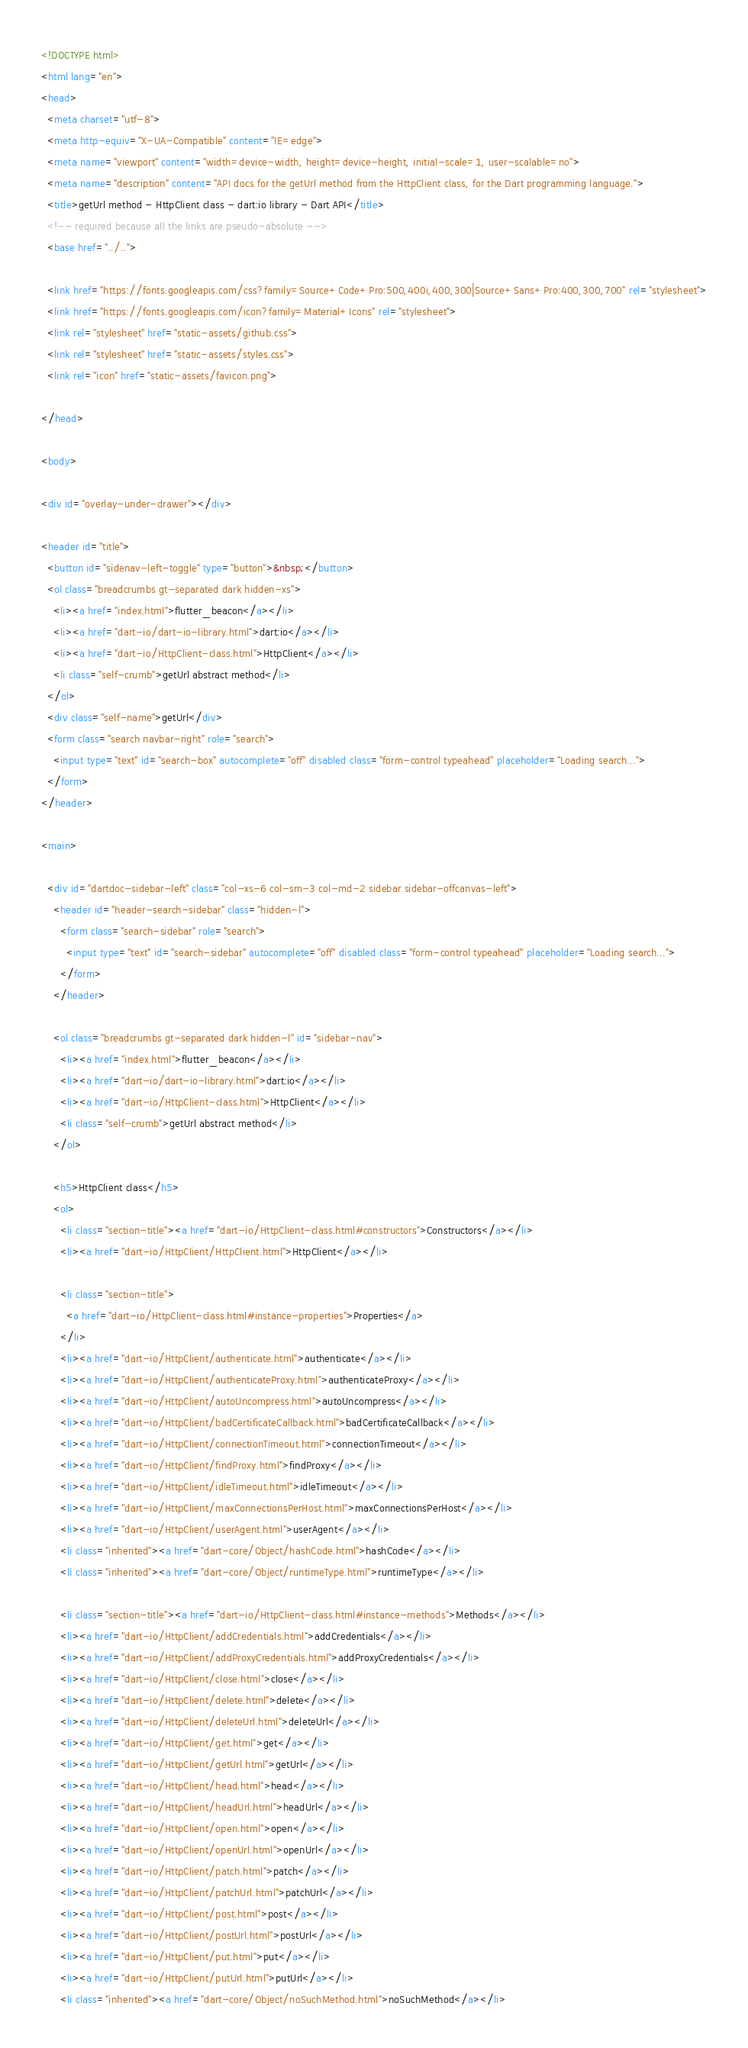<code> <loc_0><loc_0><loc_500><loc_500><_HTML_><!DOCTYPE html>
<html lang="en">
<head>
  <meta charset="utf-8">
  <meta http-equiv="X-UA-Compatible" content="IE=edge">
  <meta name="viewport" content="width=device-width, height=device-height, initial-scale=1, user-scalable=no">
  <meta name="description" content="API docs for the getUrl method from the HttpClient class, for the Dart programming language.">
  <title>getUrl method - HttpClient class - dart:io library - Dart API</title>
  <!-- required because all the links are pseudo-absolute -->
  <base href="../..">

  <link href="https://fonts.googleapis.com/css?family=Source+Code+Pro:500,400i,400,300|Source+Sans+Pro:400,300,700" rel="stylesheet">
  <link href="https://fonts.googleapis.com/icon?family=Material+Icons" rel="stylesheet">
  <link rel="stylesheet" href="static-assets/github.css">
  <link rel="stylesheet" href="static-assets/styles.css">
  <link rel="icon" href="static-assets/favicon.png">
  
</head>

<body>

<div id="overlay-under-drawer"></div>

<header id="title">
  <button id="sidenav-left-toggle" type="button">&nbsp;</button>
  <ol class="breadcrumbs gt-separated dark hidden-xs">
    <li><a href="index.html">flutter_beacon</a></li>
    <li><a href="dart-io/dart-io-library.html">dart:io</a></li>
    <li><a href="dart-io/HttpClient-class.html">HttpClient</a></li>
    <li class="self-crumb">getUrl abstract method</li>
  </ol>
  <div class="self-name">getUrl</div>
  <form class="search navbar-right" role="search">
    <input type="text" id="search-box" autocomplete="off" disabled class="form-control typeahead" placeholder="Loading search...">
  </form>
</header>

<main>

  <div id="dartdoc-sidebar-left" class="col-xs-6 col-sm-3 col-md-2 sidebar sidebar-offcanvas-left">
    <header id="header-search-sidebar" class="hidden-l">
      <form class="search-sidebar" role="search">
        <input type="text" id="search-sidebar" autocomplete="off" disabled class="form-control typeahead" placeholder="Loading search...">
      </form>
    </header>
    
    <ol class="breadcrumbs gt-separated dark hidden-l" id="sidebar-nav">
      <li><a href="index.html">flutter_beacon</a></li>
      <li><a href="dart-io/dart-io-library.html">dart:io</a></li>
      <li><a href="dart-io/HttpClient-class.html">HttpClient</a></li>
      <li class="self-crumb">getUrl abstract method</li>
    </ol>
    
    <h5>HttpClient class</h5>
    <ol>
      <li class="section-title"><a href="dart-io/HttpClient-class.html#constructors">Constructors</a></li>
      <li><a href="dart-io/HttpClient/HttpClient.html">HttpClient</a></li>
    
      <li class="section-title">
        <a href="dart-io/HttpClient-class.html#instance-properties">Properties</a>
      </li>
      <li><a href="dart-io/HttpClient/authenticate.html">authenticate</a></li>
      <li><a href="dart-io/HttpClient/authenticateProxy.html">authenticateProxy</a></li>
      <li><a href="dart-io/HttpClient/autoUncompress.html">autoUncompress</a></li>
      <li><a href="dart-io/HttpClient/badCertificateCallback.html">badCertificateCallback</a></li>
      <li><a href="dart-io/HttpClient/connectionTimeout.html">connectionTimeout</a></li>
      <li><a href="dart-io/HttpClient/findProxy.html">findProxy</a></li>
      <li><a href="dart-io/HttpClient/idleTimeout.html">idleTimeout</a></li>
      <li><a href="dart-io/HttpClient/maxConnectionsPerHost.html">maxConnectionsPerHost</a></li>
      <li><a href="dart-io/HttpClient/userAgent.html">userAgent</a></li>
      <li class="inherited"><a href="dart-core/Object/hashCode.html">hashCode</a></li>
      <li class="inherited"><a href="dart-core/Object/runtimeType.html">runtimeType</a></li>
    
      <li class="section-title"><a href="dart-io/HttpClient-class.html#instance-methods">Methods</a></li>
      <li><a href="dart-io/HttpClient/addCredentials.html">addCredentials</a></li>
      <li><a href="dart-io/HttpClient/addProxyCredentials.html">addProxyCredentials</a></li>
      <li><a href="dart-io/HttpClient/close.html">close</a></li>
      <li><a href="dart-io/HttpClient/delete.html">delete</a></li>
      <li><a href="dart-io/HttpClient/deleteUrl.html">deleteUrl</a></li>
      <li><a href="dart-io/HttpClient/get.html">get</a></li>
      <li><a href="dart-io/HttpClient/getUrl.html">getUrl</a></li>
      <li><a href="dart-io/HttpClient/head.html">head</a></li>
      <li><a href="dart-io/HttpClient/headUrl.html">headUrl</a></li>
      <li><a href="dart-io/HttpClient/open.html">open</a></li>
      <li><a href="dart-io/HttpClient/openUrl.html">openUrl</a></li>
      <li><a href="dart-io/HttpClient/patch.html">patch</a></li>
      <li><a href="dart-io/HttpClient/patchUrl.html">patchUrl</a></li>
      <li><a href="dart-io/HttpClient/post.html">post</a></li>
      <li><a href="dart-io/HttpClient/postUrl.html">postUrl</a></li>
      <li><a href="dart-io/HttpClient/put.html">put</a></li>
      <li><a href="dart-io/HttpClient/putUrl.html">putUrl</a></li>
      <li class="inherited"><a href="dart-core/Object/noSuchMethod.html">noSuchMethod</a></li></code> 